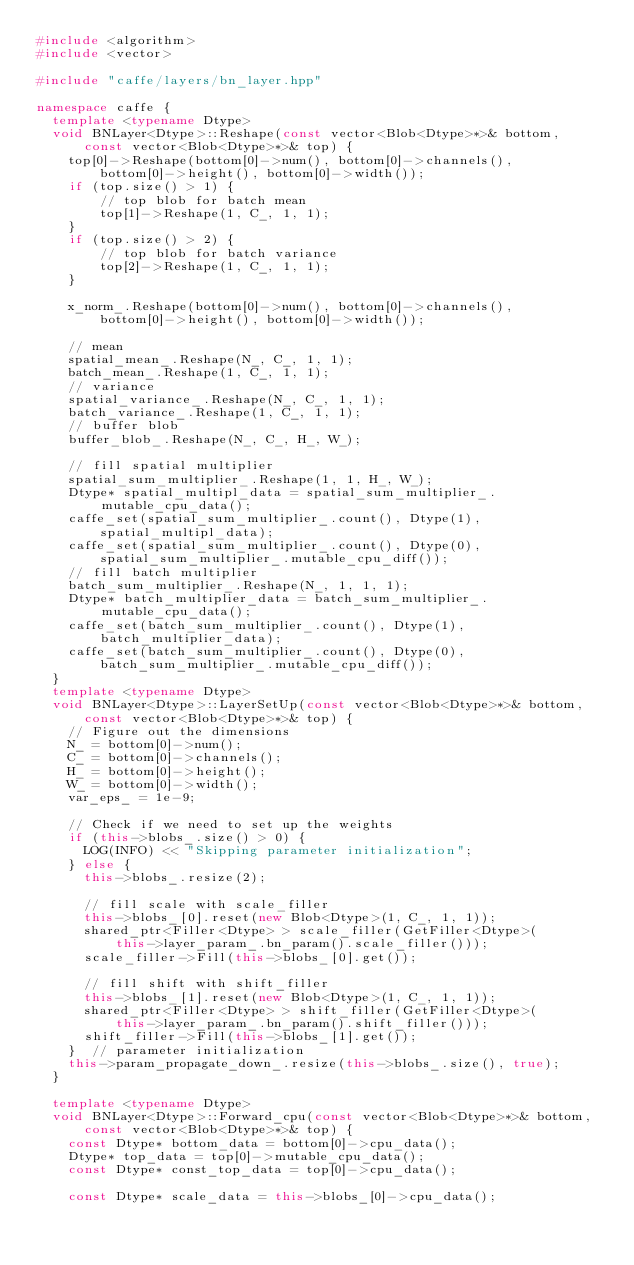<code> <loc_0><loc_0><loc_500><loc_500><_C++_>#include <algorithm>
#include <vector>

#include "caffe/layers/bn_layer.hpp"

namespace caffe {
  template <typename Dtype>
  void BNLayer<Dtype>::Reshape(const vector<Blob<Dtype>*>& bottom,
      const vector<Blob<Dtype>*>& top) {
    top[0]->Reshape(bottom[0]->num(), bottom[0]->channels(),
        bottom[0]->height(), bottom[0]->width());
    if (top.size() > 1) {
        // top blob for batch mean
        top[1]->Reshape(1, C_, 1, 1);
    }
    if (top.size() > 2) {
        // top blob for batch variance
        top[2]->Reshape(1, C_, 1, 1);
    }

    x_norm_.Reshape(bottom[0]->num(), bottom[0]->channels(),
        bottom[0]->height(), bottom[0]->width());

    // mean
    spatial_mean_.Reshape(N_, C_, 1, 1);
    batch_mean_.Reshape(1, C_, 1, 1);
    // variance
    spatial_variance_.Reshape(N_, C_, 1, 1);
    batch_variance_.Reshape(1, C_, 1, 1);
    // buffer blob
    buffer_blob_.Reshape(N_, C_, H_, W_);

    // fill spatial multiplier
    spatial_sum_multiplier_.Reshape(1, 1, H_, W_);
    Dtype* spatial_multipl_data = spatial_sum_multiplier_.mutable_cpu_data();
    caffe_set(spatial_sum_multiplier_.count(), Dtype(1),
        spatial_multipl_data);
    caffe_set(spatial_sum_multiplier_.count(), Dtype(0),
        spatial_sum_multiplier_.mutable_cpu_diff());
    // fill batch multiplier
    batch_sum_multiplier_.Reshape(N_, 1, 1, 1);
    Dtype* batch_multiplier_data = batch_sum_multiplier_.mutable_cpu_data();
    caffe_set(batch_sum_multiplier_.count(), Dtype(1),
        batch_multiplier_data);
    caffe_set(batch_sum_multiplier_.count(), Dtype(0),
        batch_sum_multiplier_.mutable_cpu_diff());
  }
  template <typename Dtype>
  void BNLayer<Dtype>::LayerSetUp(const vector<Blob<Dtype>*>& bottom,
      const vector<Blob<Dtype>*>& top) {
    // Figure out the dimensions
    N_ = bottom[0]->num();
    C_ = bottom[0]->channels();
    H_ = bottom[0]->height();
    W_ = bottom[0]->width();
    var_eps_ = 1e-9;

    // Check if we need to set up the weights
    if (this->blobs_.size() > 0) {
      LOG(INFO) << "Skipping parameter initialization";
    } else {
      this->blobs_.resize(2);

      // fill scale with scale_filler
      this->blobs_[0].reset(new Blob<Dtype>(1, C_, 1, 1));
      shared_ptr<Filler<Dtype> > scale_filler(GetFiller<Dtype>(
          this->layer_param_.bn_param().scale_filler()));
      scale_filler->Fill(this->blobs_[0].get());

      // fill shift with shift_filler
      this->blobs_[1].reset(new Blob<Dtype>(1, C_, 1, 1));
      shared_ptr<Filler<Dtype> > shift_filler(GetFiller<Dtype>(
          this->layer_param_.bn_param().shift_filler()));
      shift_filler->Fill(this->blobs_[1].get());
    }  // parameter initialization
    this->param_propagate_down_.resize(this->blobs_.size(), true);
  }

  template <typename Dtype>
  void BNLayer<Dtype>::Forward_cpu(const vector<Blob<Dtype>*>& bottom,
      const vector<Blob<Dtype>*>& top) {
    const Dtype* bottom_data = bottom[0]->cpu_data();
    Dtype* top_data = top[0]->mutable_cpu_data();
    const Dtype* const_top_data = top[0]->cpu_data();

    const Dtype* scale_data = this->blobs_[0]->cpu_data();</code> 